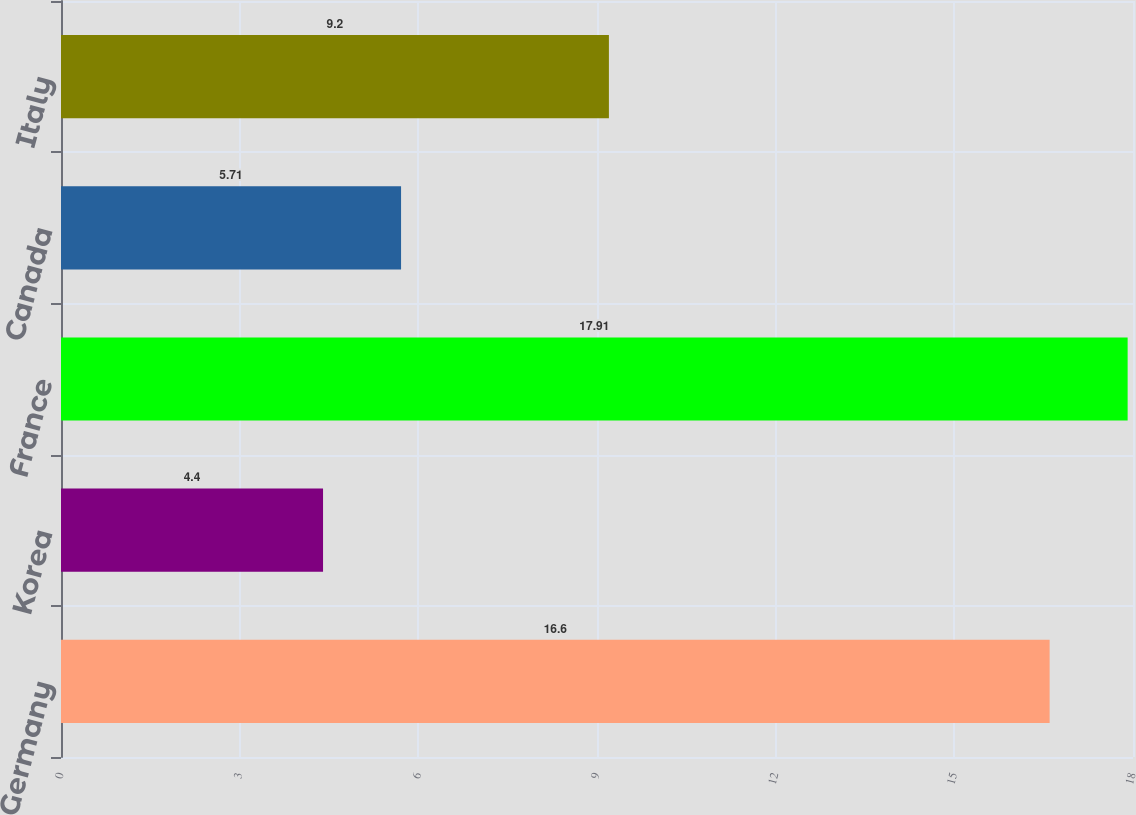<chart> <loc_0><loc_0><loc_500><loc_500><bar_chart><fcel>Germany<fcel>Korea<fcel>France<fcel>Canada<fcel>Italy<nl><fcel>16.6<fcel>4.4<fcel>17.91<fcel>5.71<fcel>9.2<nl></chart> 